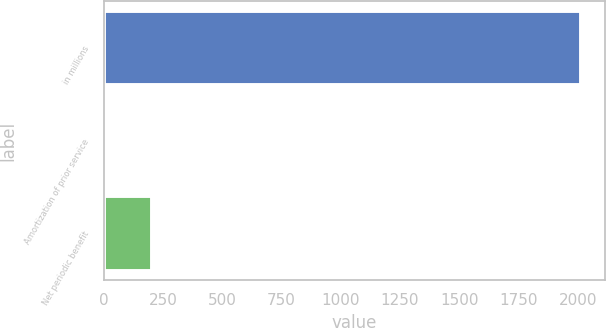Convert chart to OTSL. <chart><loc_0><loc_0><loc_500><loc_500><bar_chart><fcel>in millions<fcel>Amortization of prior service<fcel>Net periodic benefit<nl><fcel>2014<fcel>2.3<fcel>203.47<nl></chart> 